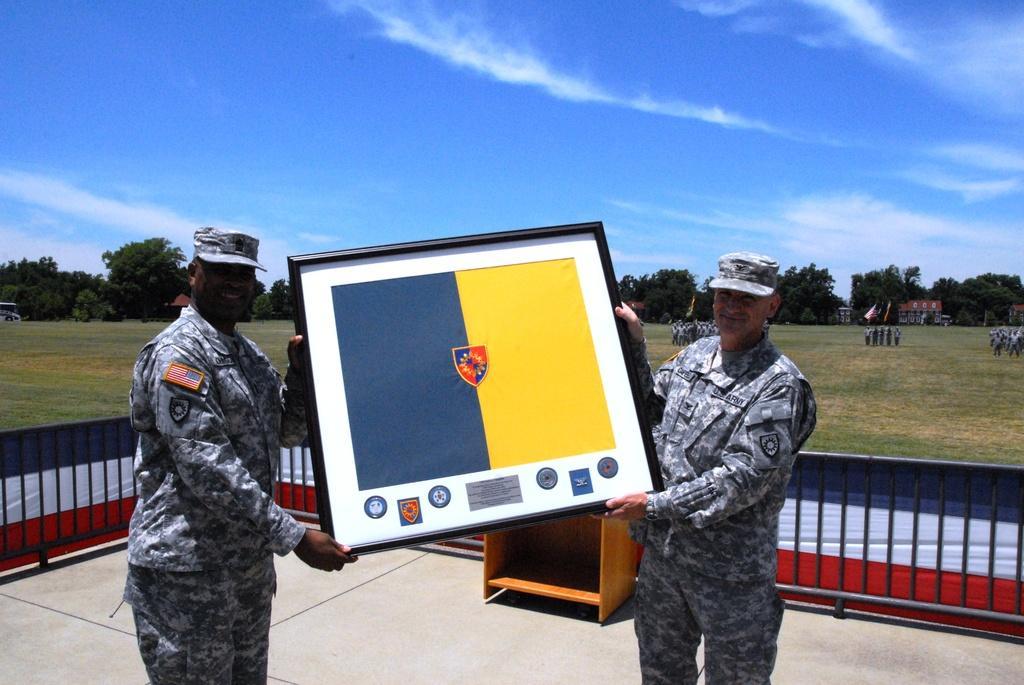Describe this image in one or two sentences. In front of the image there are two army personnel holding a photo frame, behind them there is a wooden object, behind the object there is a metal rod fence covered with a cloth, in the background of the image there are a few people standing by holding flags, behind them there are trees and buildings, at the top of the image there are clouds in the sky. 